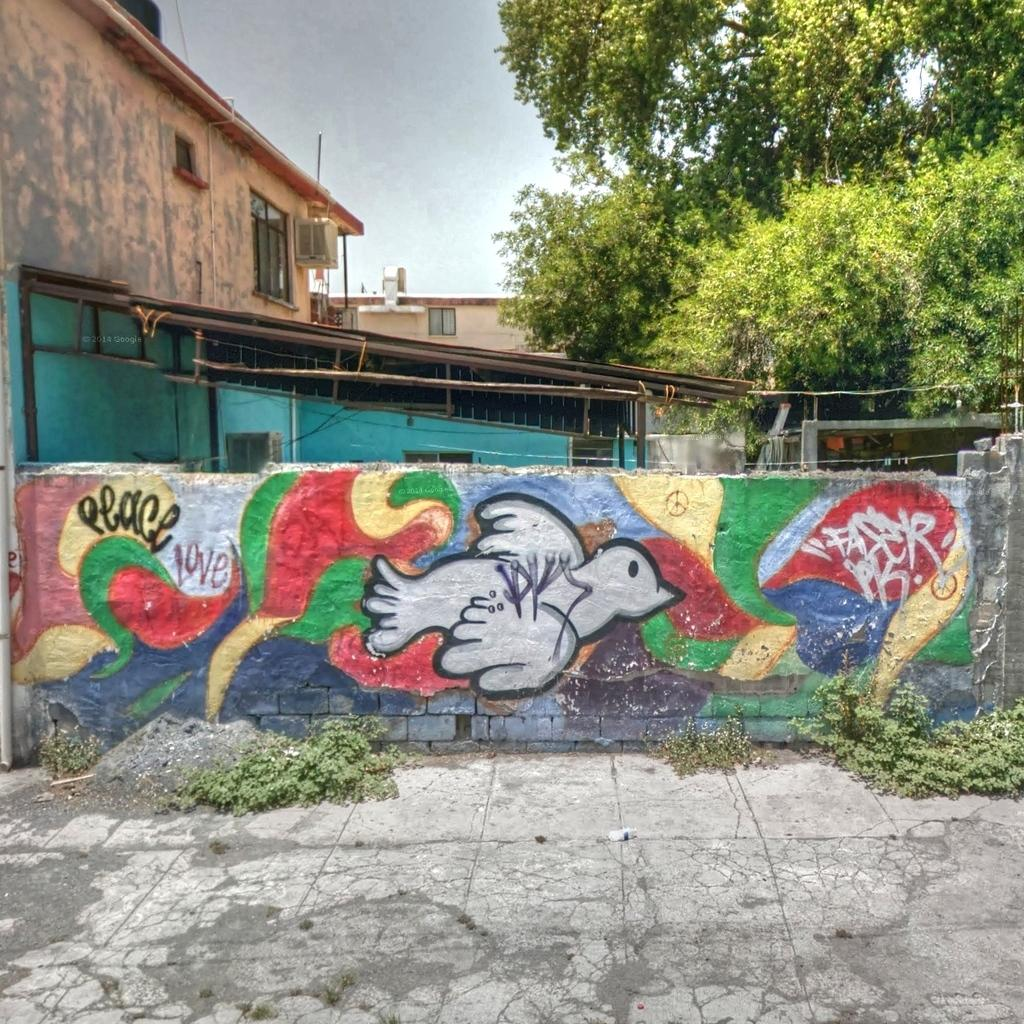What is on the wall in the image? There is graffiti paint on the wall in the image. What can be seen behind the wall? There is a building behind the wall. What type of vegetation is visible in the image? There is a tree and small plants visible in the image. What is in front of the wall? There is a floor in front of the wall. How many screws can be seen holding the tree in place in the image? There are no screws visible in the image, as trees do not require screws to be held in place. 